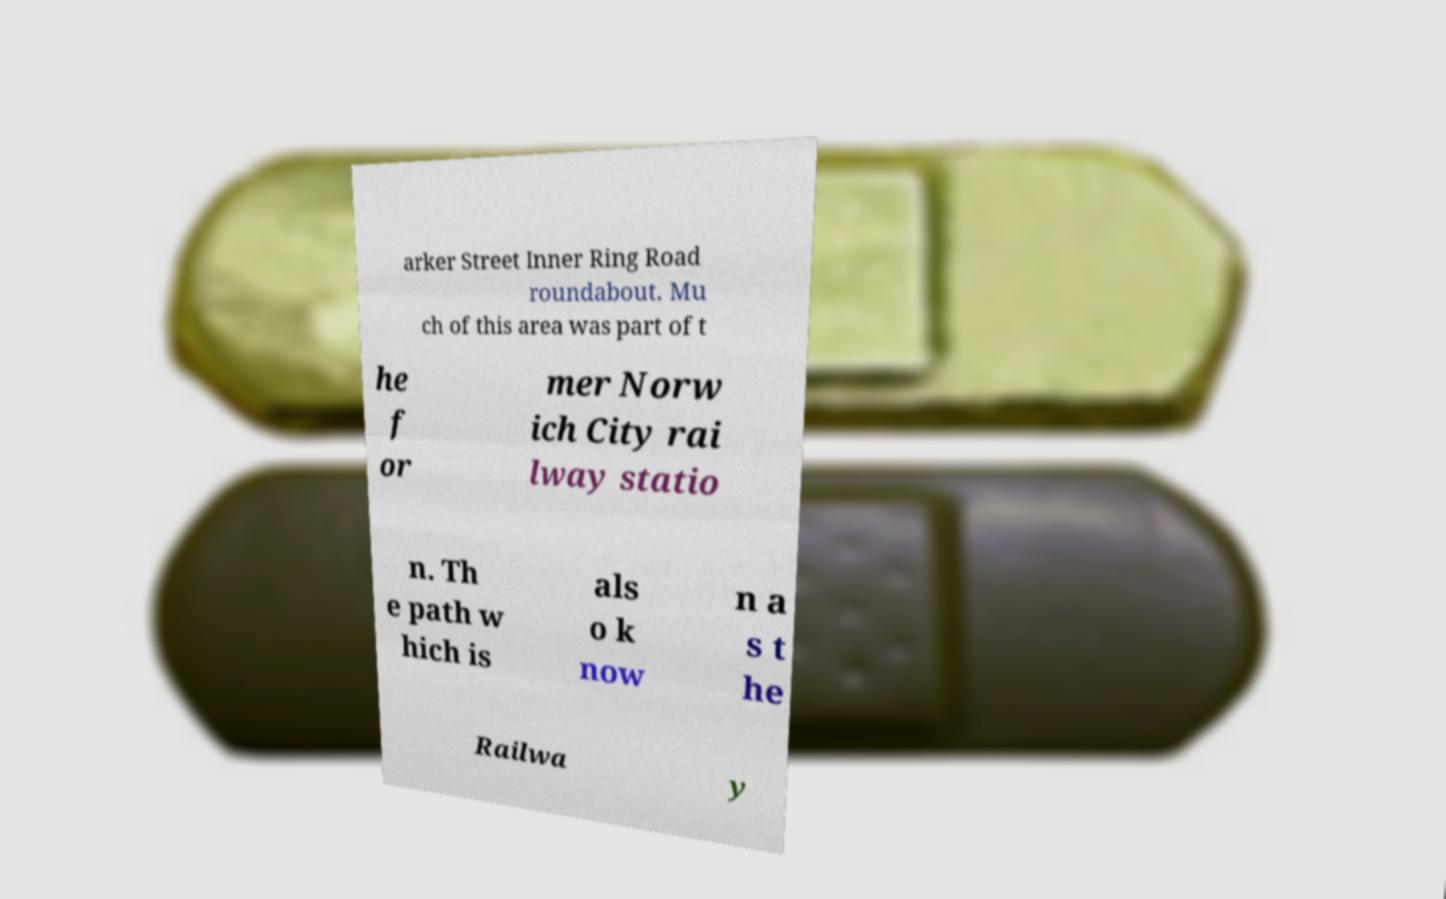For documentation purposes, I need the text within this image transcribed. Could you provide that? arker Street Inner Ring Road roundabout. Mu ch of this area was part of t he f or mer Norw ich City rai lway statio n. Th e path w hich is als o k now n a s t he Railwa y 